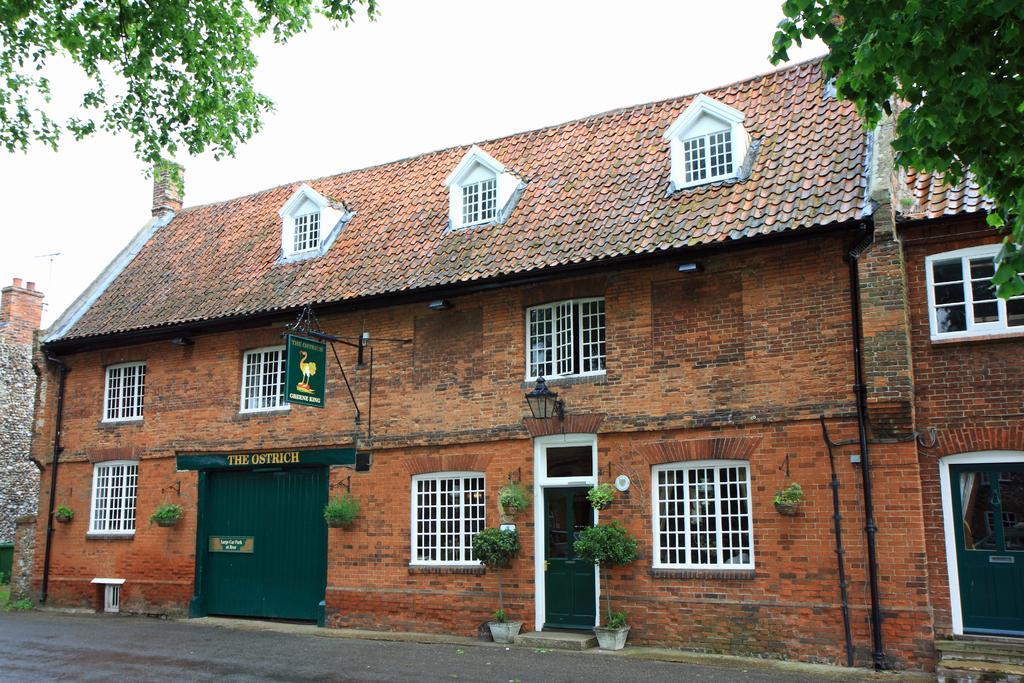How would you summarize this image in a sentence or two? At the bottom of this image I can see the road. Beside the road there is a building. At the top of the image I can see the sky and also the leaves of a tree. 